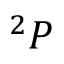Convert formula to latex. <formula><loc_0><loc_0><loc_500><loc_500>^ { 2 } P</formula> 